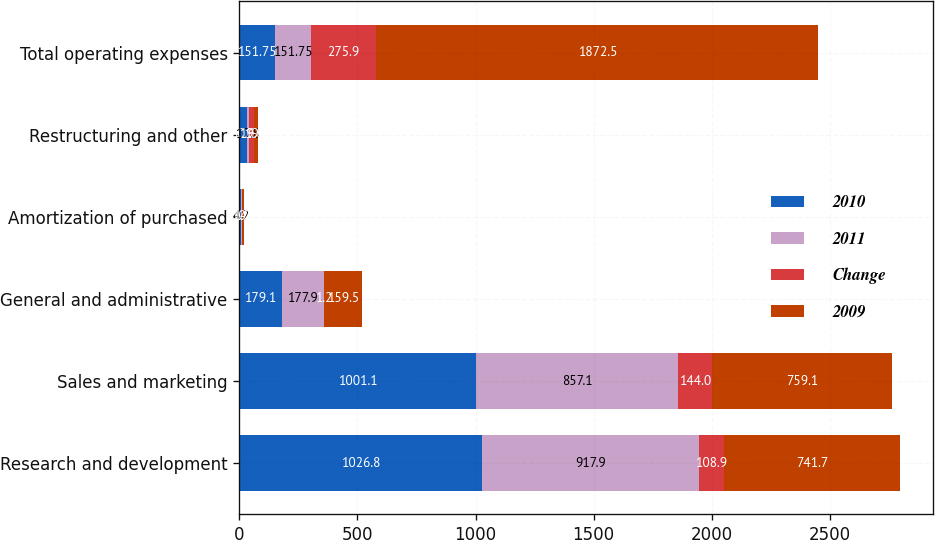<chart> <loc_0><loc_0><loc_500><loc_500><stacked_bar_chart><ecel><fcel>Research and development<fcel>Sales and marketing<fcel>General and administrative<fcel>Amortization of purchased<fcel>Restructuring and other<fcel>Total operating expenses<nl><fcel>2010<fcel>1026.8<fcel>1001.1<fcel>179.1<fcel>5.4<fcel>30.6<fcel>151.75<nl><fcel>2011<fcel>917.9<fcel>857.1<fcel>177.9<fcel>4.2<fcel>10.8<fcel>151.75<nl><fcel>Change<fcel>108.9<fcel>144<fcel>1.2<fcel>1.2<fcel>19.8<fcel>275.9<nl><fcel>2009<fcel>741.7<fcel>759.1<fcel>159.5<fcel>10.4<fcel>19.5<fcel>1872.5<nl></chart> 